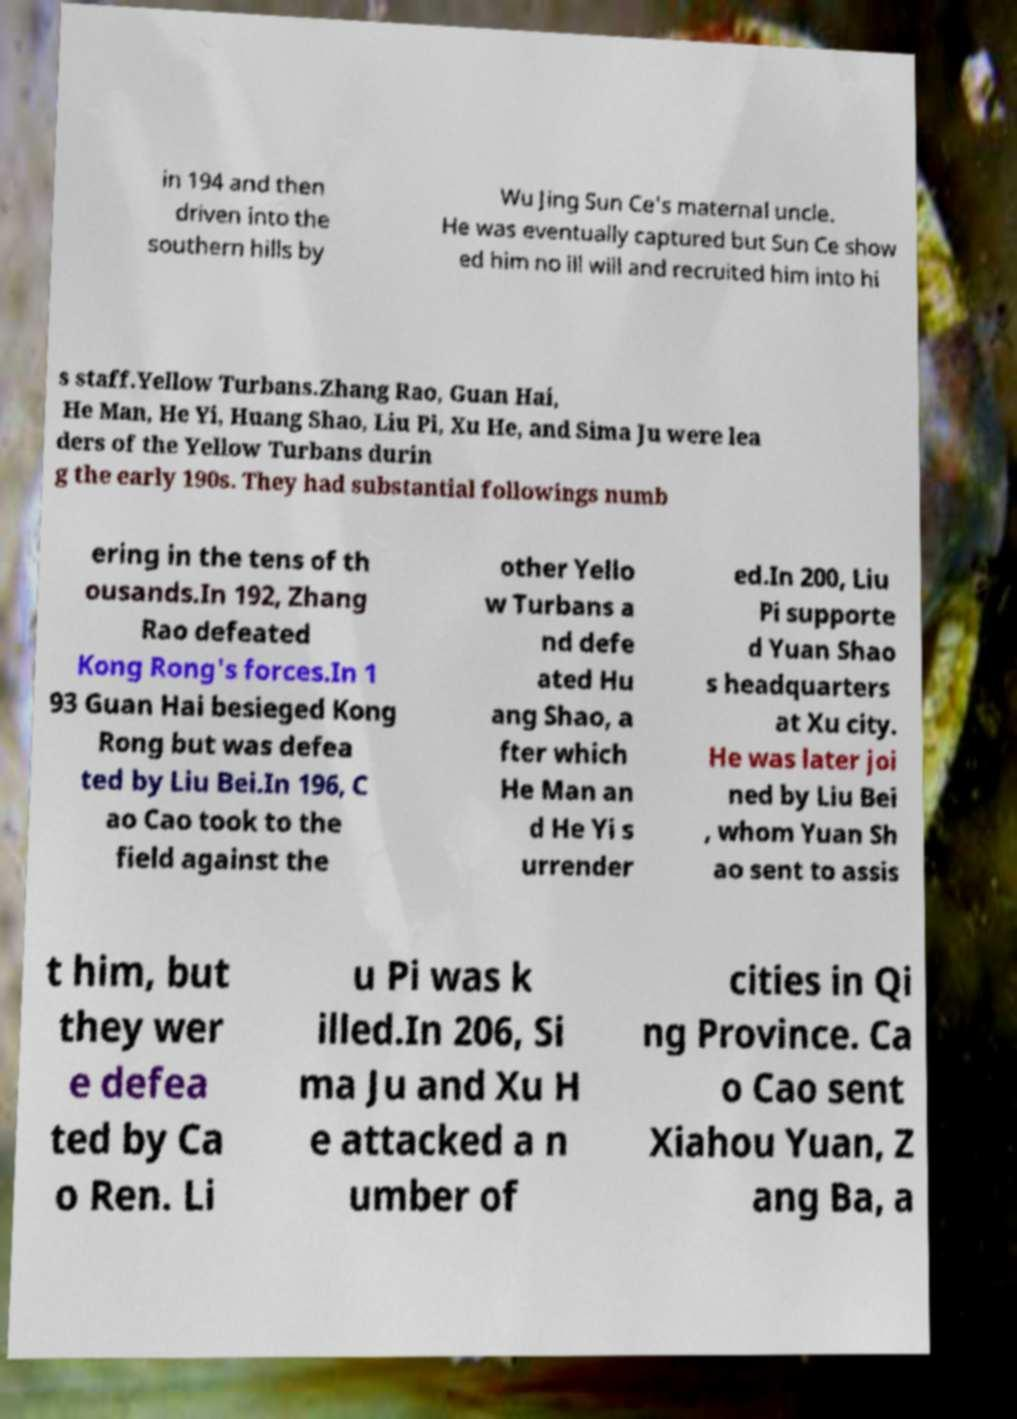Could you assist in decoding the text presented in this image and type it out clearly? in 194 and then driven into the southern hills by Wu Jing Sun Ce's maternal uncle. He was eventually captured but Sun Ce show ed him no ill will and recruited him into hi s staff.Yellow Turbans.Zhang Rao, Guan Hai, He Man, He Yi, Huang Shao, Liu Pi, Xu He, and Sima Ju were lea ders of the Yellow Turbans durin g the early 190s. They had substantial followings numb ering in the tens of th ousands.In 192, Zhang Rao defeated Kong Rong's forces.In 1 93 Guan Hai besieged Kong Rong but was defea ted by Liu Bei.In 196, C ao Cao took to the field against the other Yello w Turbans a nd defe ated Hu ang Shao, a fter which He Man an d He Yi s urrender ed.In 200, Liu Pi supporte d Yuan Shao s headquarters at Xu city. He was later joi ned by Liu Bei , whom Yuan Sh ao sent to assis t him, but they wer e defea ted by Ca o Ren. Li u Pi was k illed.In 206, Si ma Ju and Xu H e attacked a n umber of cities in Qi ng Province. Ca o Cao sent Xiahou Yuan, Z ang Ba, a 